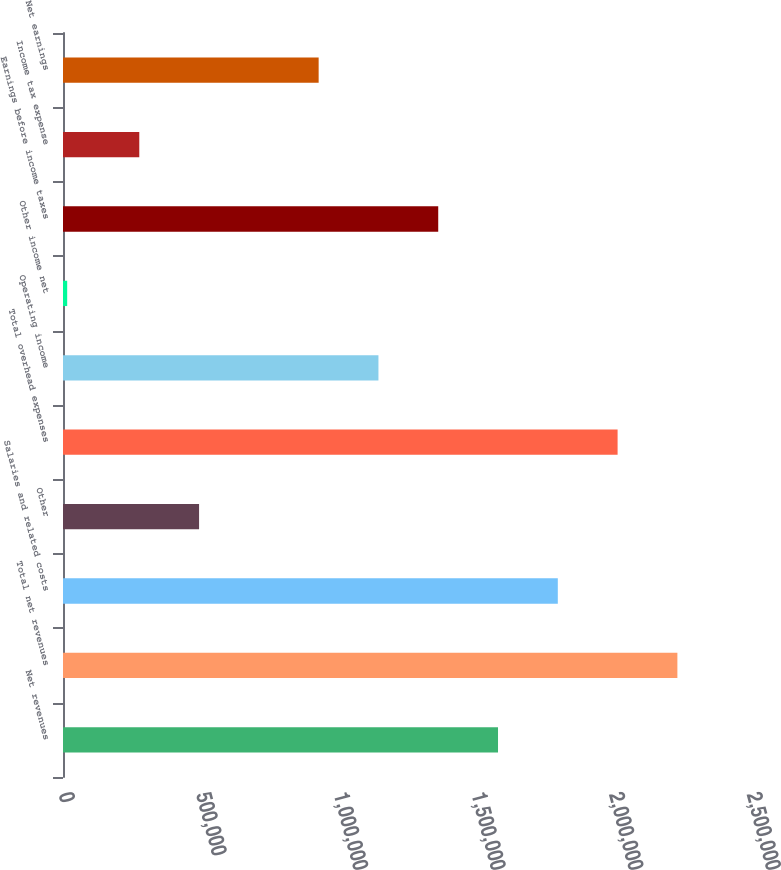<chart> <loc_0><loc_0><loc_500><loc_500><bar_chart><fcel>Net revenues<fcel>Total net revenues<fcel>Salaries and related costs<fcel>Other<fcel>Total overhead expenses<fcel>Operating income<fcel>Other income net<fcel>Earnings before income taxes<fcel>Income tax expense<fcel>Net earnings<nl><fcel>1.58074e+06<fcel>2.23251e+06<fcel>1.79799e+06<fcel>494449<fcel>2.01525e+06<fcel>1.14622e+06<fcel>15205<fcel>1.36348e+06<fcel>277192<fcel>928964<nl></chart> 